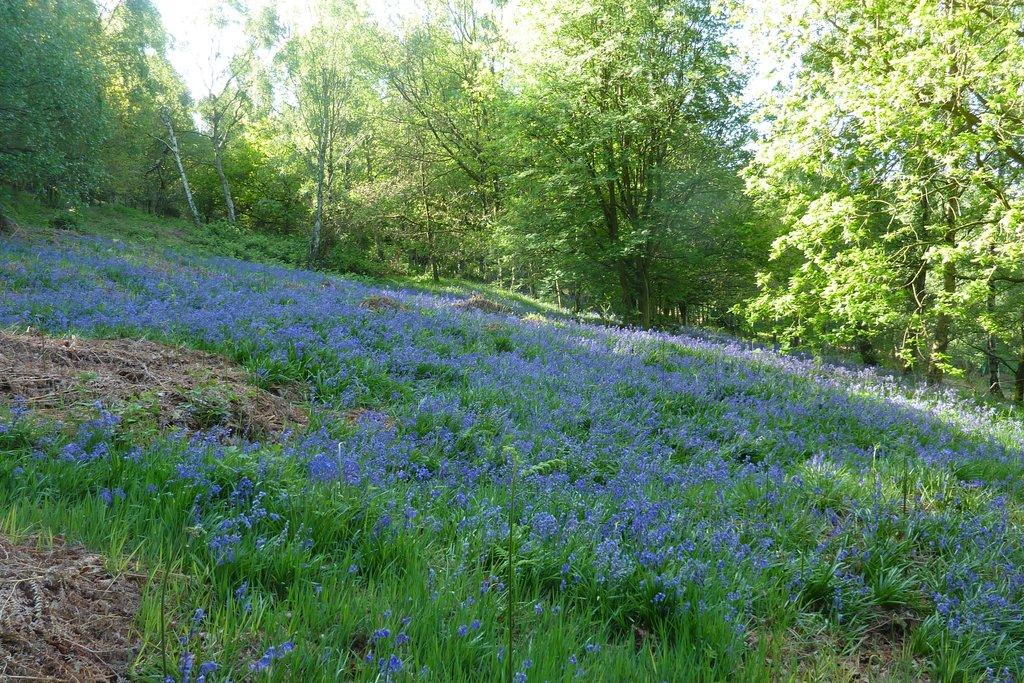What type of vegetation can be seen in the image? There is a lot of greenery in the image, including grass and trees. Can you describe the color of the flowers in the image? There are purple flowers in the grass. What type of hydrant can be seen in the image? There is no hydrant present in the image. How does the weather affect the growth of the trees in the image? The provided facts do not mention any weather conditions, so we cannot determine how the weather affects the growth of the trees in the image. 